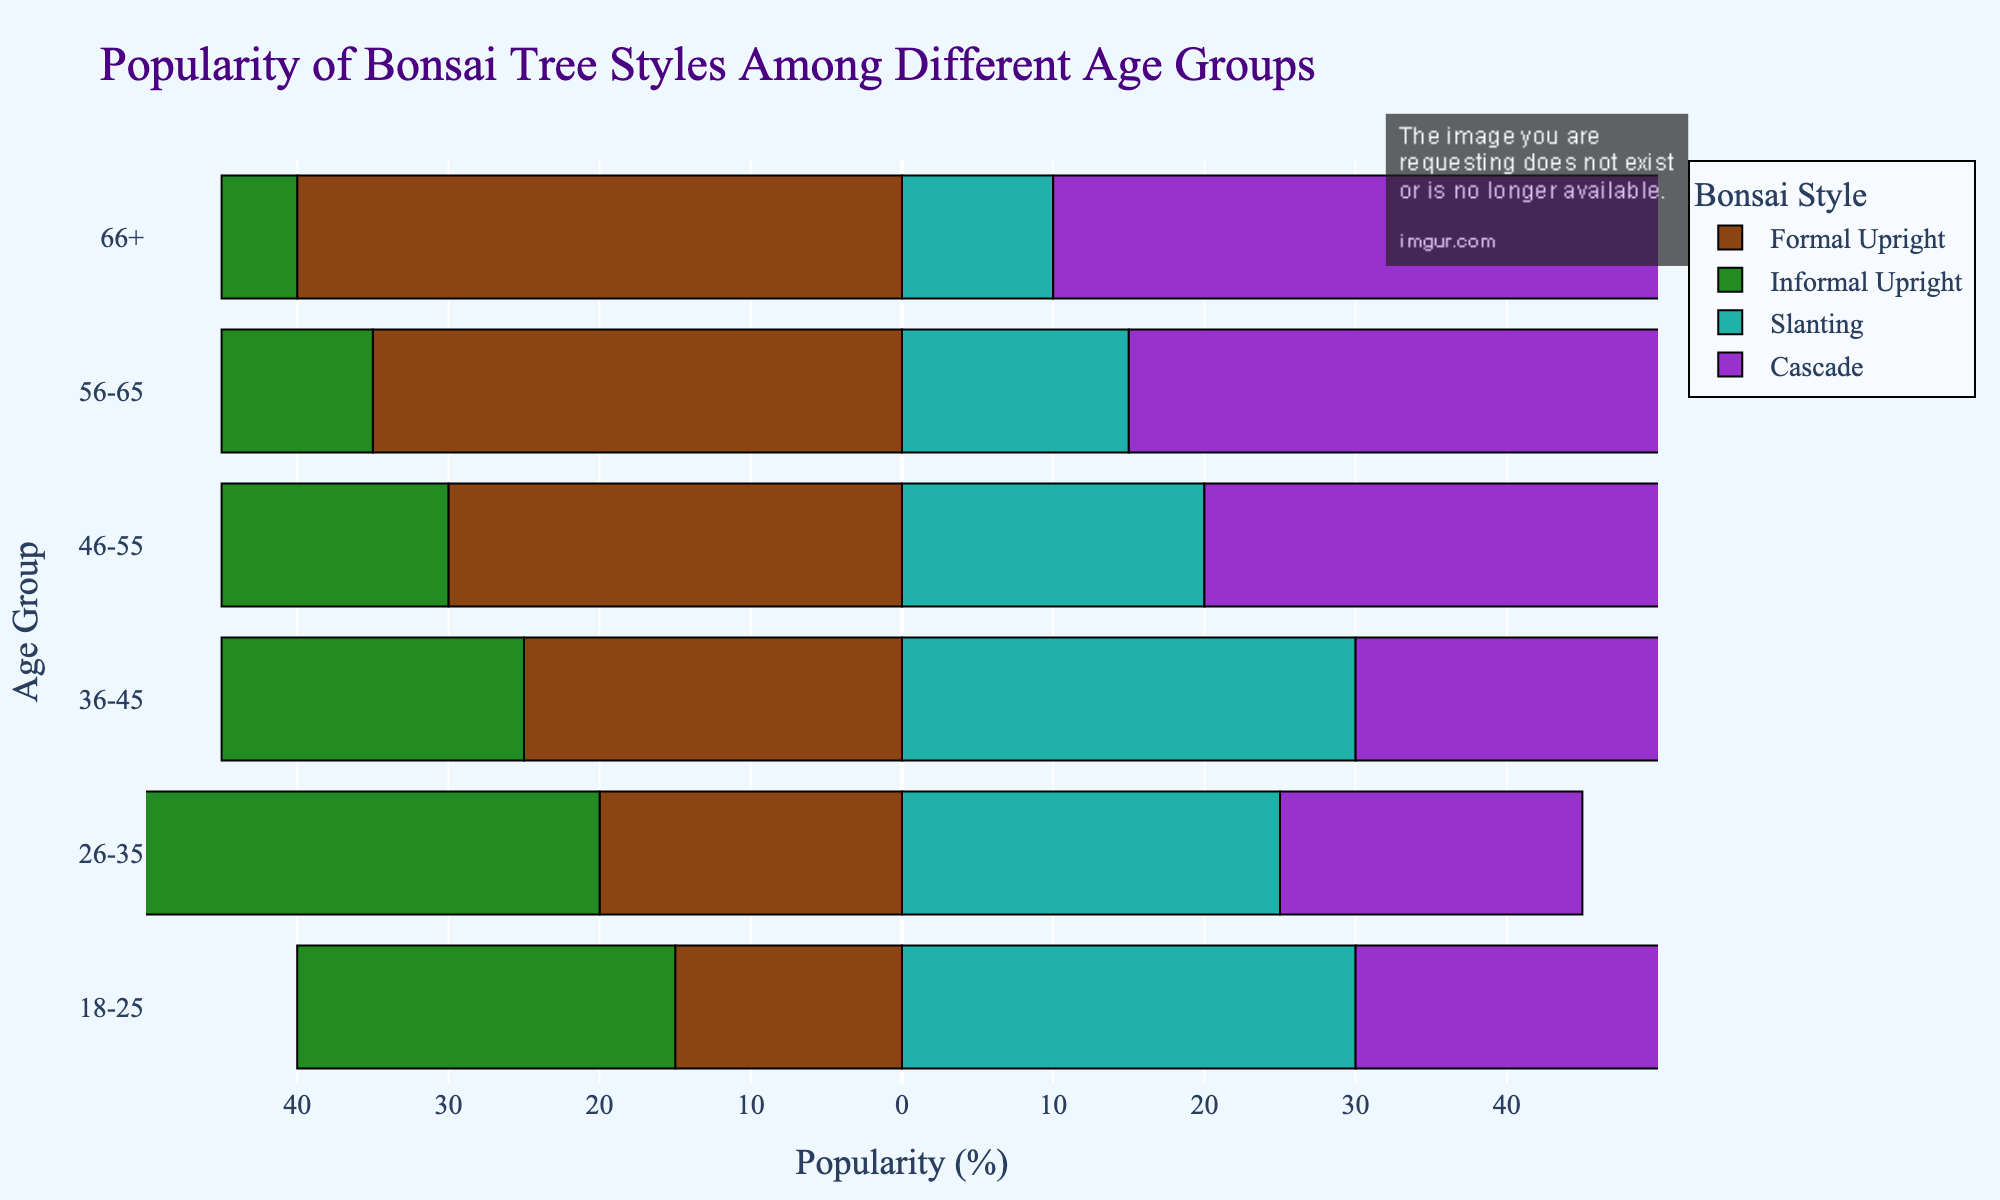Which age group has the highest popularity for the Cascade style? By looking at the bar lengths for the Cascade style, the 66+ age group has the longest bar, indicating the highest popularity.
Answer: 66+ What is the difference in popularity between the Formal Upright style for the 18-25 age group and the 66+ age group? The popularity of the Formal Upright style is represented by negative values. For 18-25, it's -15, and for 66+, it's -40. The difference in absolute value is 40 - 15 = 25.
Answer: 25 Which two age groups have the same popularity percentage for the Slanting style? The bars for the Slanting style align at the same length for the 18-25 and 36-45 age groups, both showing a 30% popularity.
Answer: 18-25 and 36-45 What is the total popularity (in percentage) of the Informal Upright style for all age groups combined? Summing up the absolute values of Informal Upright percentages across all age groups: 25 + 35 + 20 + 15 + 10 + 5 = 110%.
Answer: 110% Which bonsai style is the most favored by the 56-65 age group, and what is its percentage? By comparing the bar lengths for the 56-65 age group, Cascade has the longest bar with a 40% popularity rate.
Answer: Cascade, 40% Which style shows a decreasing trend in popularity as the age group increases? The Informal Upright style shows progressively shorter bars from younger to older age groups, indicating a decreasing trend.
Answer: Informal Upright How much more popular is the Cascade style in the 66+ age group compared to the 26-35 age group? The Cascade popularity in the 66+ age group is 45%, while it's 20% in the 26-35 age group. The difference is 45 - 20 = 25%.
Answer: 25% Overall, which style seems to be the least popular among the 46-55 age group? The Informal Upright style has the shortest bar for the 46-55 age group, indicating the least popularity.
Answer: Informal Upright Which age group has the highest cumulative popularity for all bonsai styles combined? Adding the percentages for all styles for each age group.
For 18-25: 15 + 25 + 30 + 30 = 100.
For 26-35: 20 + 35 + 25 + 20 = 100.
For 36-45: 25 + 20 + 30 + 25 = 100.
For 46-55: 30 + 15 + 20 + 35 = 100.
For 56-65: 35 + 10 + 15 + 40 = 100.
For 66+: 40 + 5 + 10 + 45 = 100.
Each age group has a total of 100%. In this specific data set, all age groups have the same total.
Answer: All age groups What is the overall trend in the popularity of the Formal Upright style among increasing age groups? By examining the bar lengths for Formal Upright from younger to older age groups, we see a consistently increasing trend, indicating rising popularity.
Answer: Increasing 